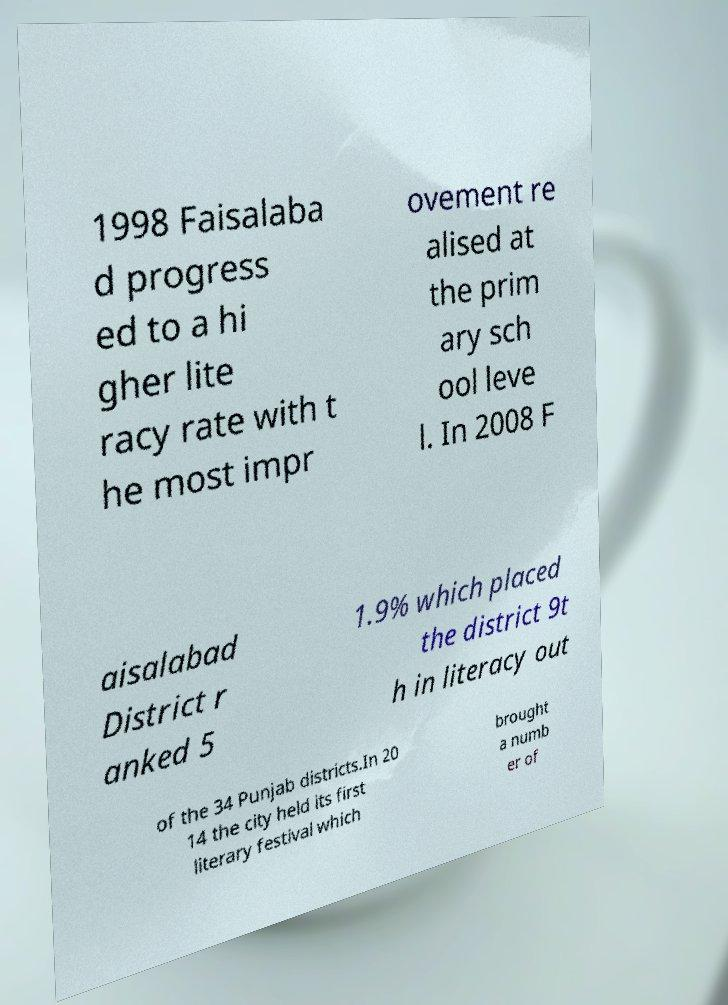Please read and relay the text visible in this image. What does it say? 1998 Faisalaba d progress ed to a hi gher lite racy rate with t he most impr ovement re alised at the prim ary sch ool leve l. In 2008 F aisalabad District r anked 5 1.9% which placed the district 9t h in literacy out of the 34 Punjab districts.In 20 14 the city held its first literary festival which brought a numb er of 